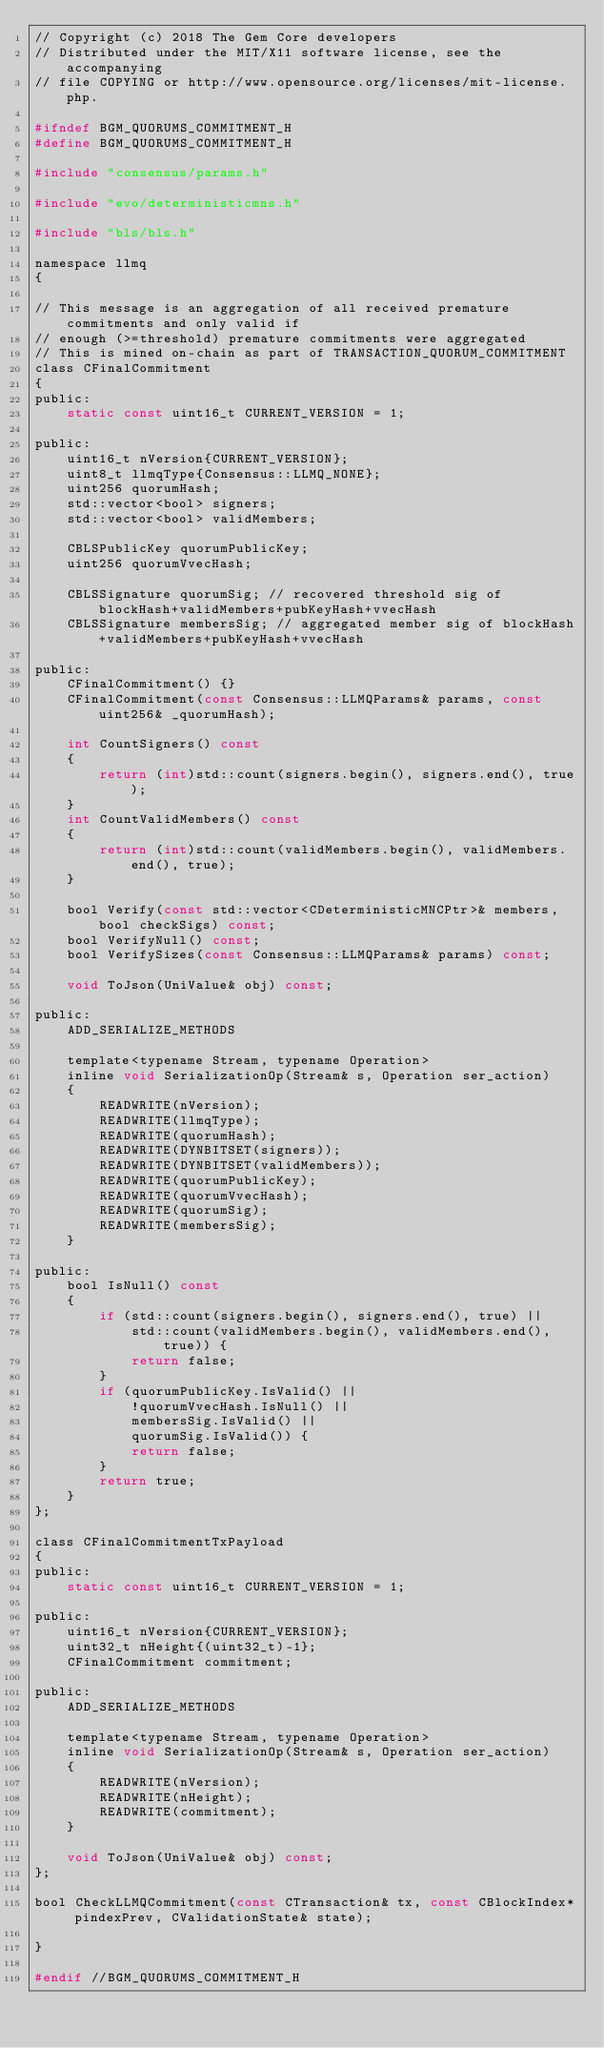<code> <loc_0><loc_0><loc_500><loc_500><_C_>// Copyright (c) 2018 The Gem Core developers
// Distributed under the MIT/X11 software license, see the accompanying
// file COPYING or http://www.opensource.org/licenses/mit-license.php.

#ifndef BGM_QUORUMS_COMMITMENT_H
#define BGM_QUORUMS_COMMITMENT_H

#include "consensus/params.h"

#include "evo/deterministicmns.h"

#include "bls/bls.h"

namespace llmq
{

// This message is an aggregation of all received premature commitments and only valid if
// enough (>=threshold) premature commitments were aggregated
// This is mined on-chain as part of TRANSACTION_QUORUM_COMMITMENT
class CFinalCommitment
{
public:
    static const uint16_t CURRENT_VERSION = 1;

public:
    uint16_t nVersion{CURRENT_VERSION};
    uint8_t llmqType{Consensus::LLMQ_NONE};
    uint256 quorumHash;
    std::vector<bool> signers;
    std::vector<bool> validMembers;

    CBLSPublicKey quorumPublicKey;
    uint256 quorumVvecHash;

    CBLSSignature quorumSig; // recovered threshold sig of blockHash+validMembers+pubKeyHash+vvecHash
    CBLSSignature membersSig; // aggregated member sig of blockHash+validMembers+pubKeyHash+vvecHash

public:
    CFinalCommitment() {}
    CFinalCommitment(const Consensus::LLMQParams& params, const uint256& _quorumHash);

    int CountSigners() const
    {
        return (int)std::count(signers.begin(), signers.end(), true);
    }
    int CountValidMembers() const
    {
        return (int)std::count(validMembers.begin(), validMembers.end(), true);
    }

    bool Verify(const std::vector<CDeterministicMNCPtr>& members, bool checkSigs) const;
    bool VerifyNull() const;
    bool VerifySizes(const Consensus::LLMQParams& params) const;

    void ToJson(UniValue& obj) const;

public:
    ADD_SERIALIZE_METHODS

    template<typename Stream, typename Operation>
    inline void SerializationOp(Stream& s, Operation ser_action)
    {
        READWRITE(nVersion);
        READWRITE(llmqType);
        READWRITE(quorumHash);
        READWRITE(DYNBITSET(signers));
        READWRITE(DYNBITSET(validMembers));
        READWRITE(quorumPublicKey);
        READWRITE(quorumVvecHash);
        READWRITE(quorumSig);
        READWRITE(membersSig);
    }

public:
    bool IsNull() const
    {
        if (std::count(signers.begin(), signers.end(), true) ||
            std::count(validMembers.begin(), validMembers.end(), true)) {
            return false;
        }
        if (quorumPublicKey.IsValid() ||
            !quorumVvecHash.IsNull() ||
            membersSig.IsValid() ||
            quorumSig.IsValid()) {
            return false;
        }
        return true;
    }
};

class CFinalCommitmentTxPayload
{
public:
    static const uint16_t CURRENT_VERSION = 1;

public:
    uint16_t nVersion{CURRENT_VERSION};
    uint32_t nHeight{(uint32_t)-1};
    CFinalCommitment commitment;

public:
    ADD_SERIALIZE_METHODS

    template<typename Stream, typename Operation>
    inline void SerializationOp(Stream& s, Operation ser_action)
    {
        READWRITE(nVersion);
        READWRITE(nHeight);
        READWRITE(commitment);
    }

    void ToJson(UniValue& obj) const;
};

bool CheckLLMQCommitment(const CTransaction& tx, const CBlockIndex* pindexPrev, CValidationState& state);

}

#endif //BGM_QUORUMS_COMMITMENT_H
</code> 